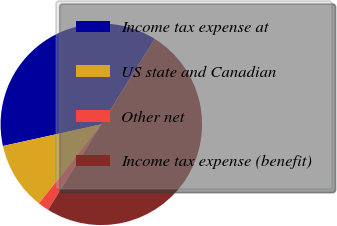<chart> <loc_0><loc_0><loc_500><loc_500><pie_chart><fcel>Income tax expense at<fcel>US state and Canadian<fcel>Other net<fcel>Income tax expense (benefit)<nl><fcel>37.34%<fcel>10.92%<fcel>1.75%<fcel>50.0%<nl></chart> 